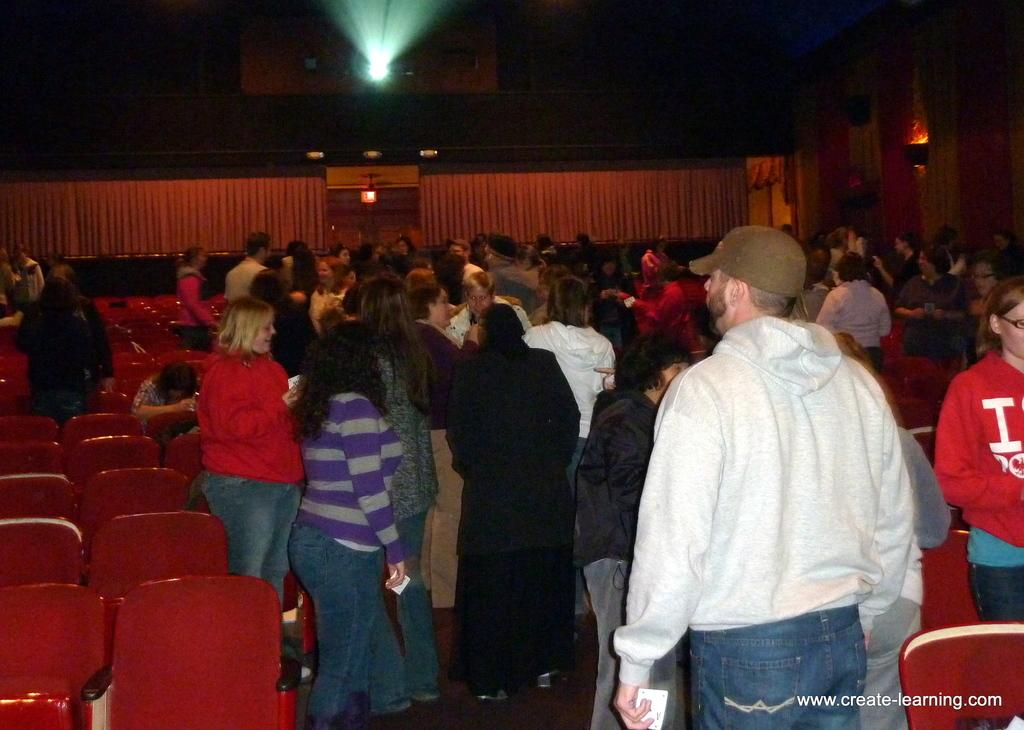What are the people in the image doing? There are people standing and sitting on chairs in the image. Can you describe the positions of the people in the image? Some people are standing, while others are sitting on chairs. What is the distance between the people and the boat in the image? There is no boat present in the image, so it is not possible to determine the distance between the people and a boat. 